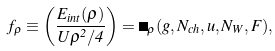<formula> <loc_0><loc_0><loc_500><loc_500>f _ { \rho } \equiv \left ( \frac { E _ { i n t } ( \rho ) } { U \rho ^ { 2 } / 4 } \right ) = \Psi _ { \rho } ( g , N _ { c h } , u , N _ { W } , F ) ,</formula> 